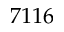<formula> <loc_0><loc_0><loc_500><loc_500>7 1 1 6</formula> 